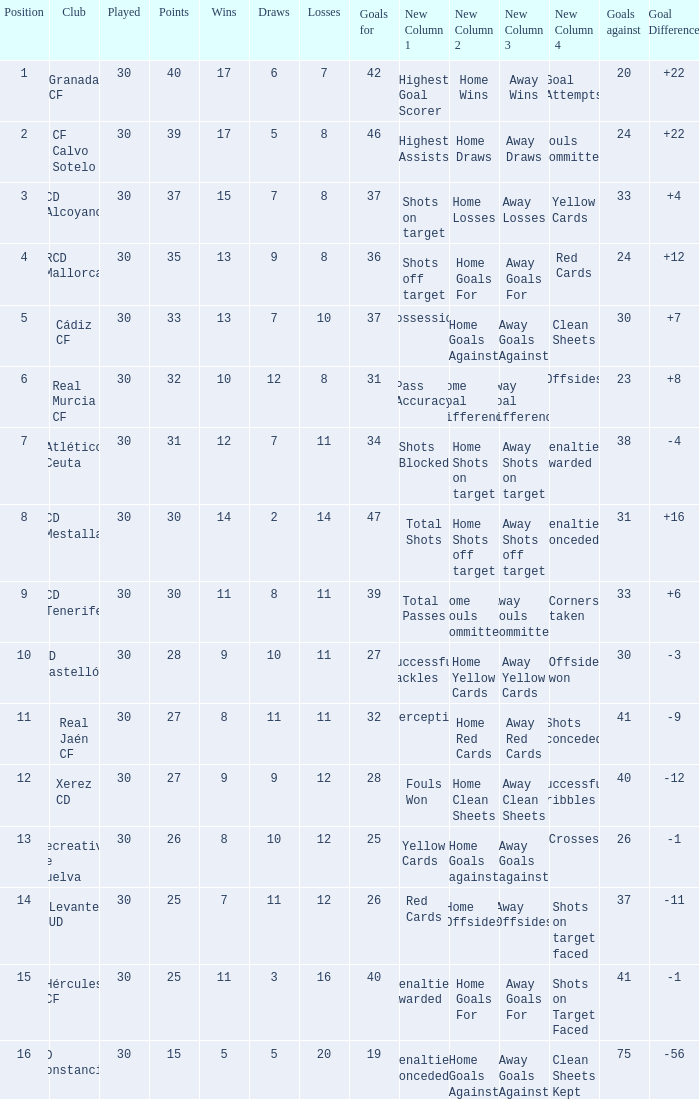How many Draws have 30 Points, and less than 33 Goals against? 1.0. 